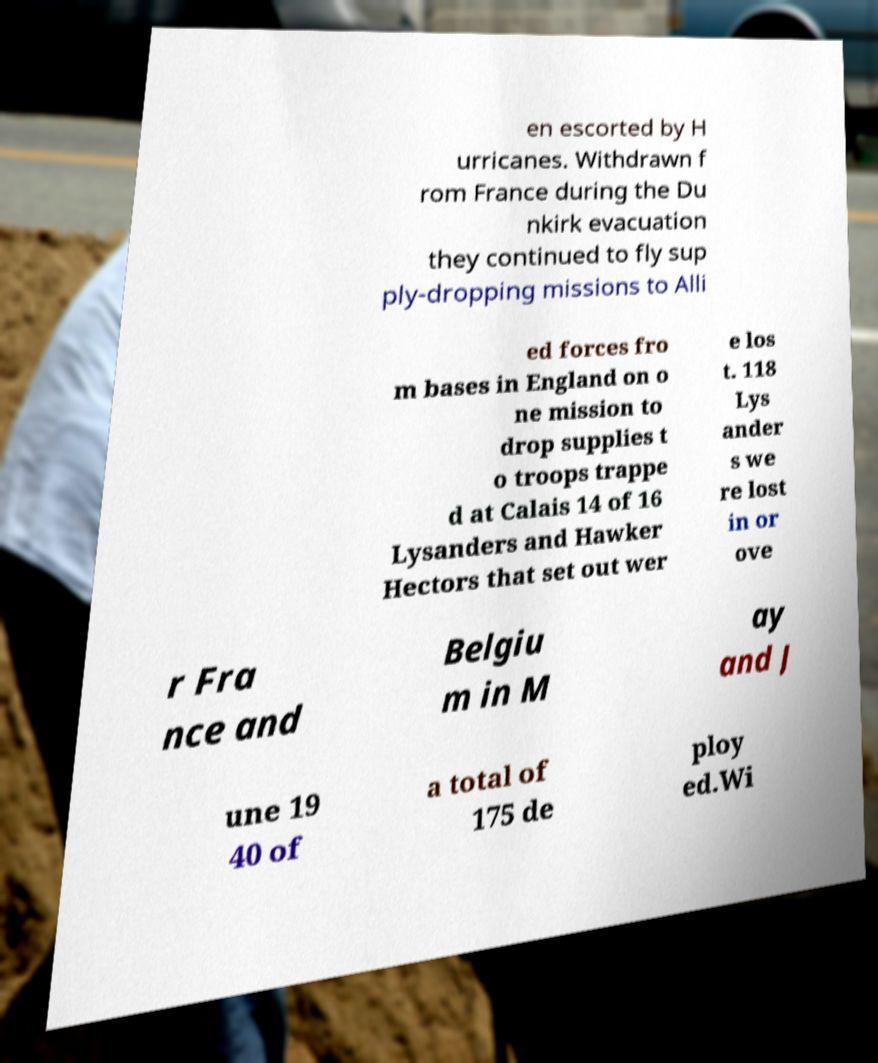Can you read and provide the text displayed in the image?This photo seems to have some interesting text. Can you extract and type it out for me? en escorted by H urricanes. Withdrawn f rom France during the Du nkirk evacuation they continued to fly sup ply-dropping missions to Alli ed forces fro m bases in England on o ne mission to drop supplies t o troops trappe d at Calais 14 of 16 Lysanders and Hawker Hectors that set out wer e los t. 118 Lys ander s we re lost in or ove r Fra nce and Belgiu m in M ay and J une 19 40 of a total of 175 de ploy ed.Wi 